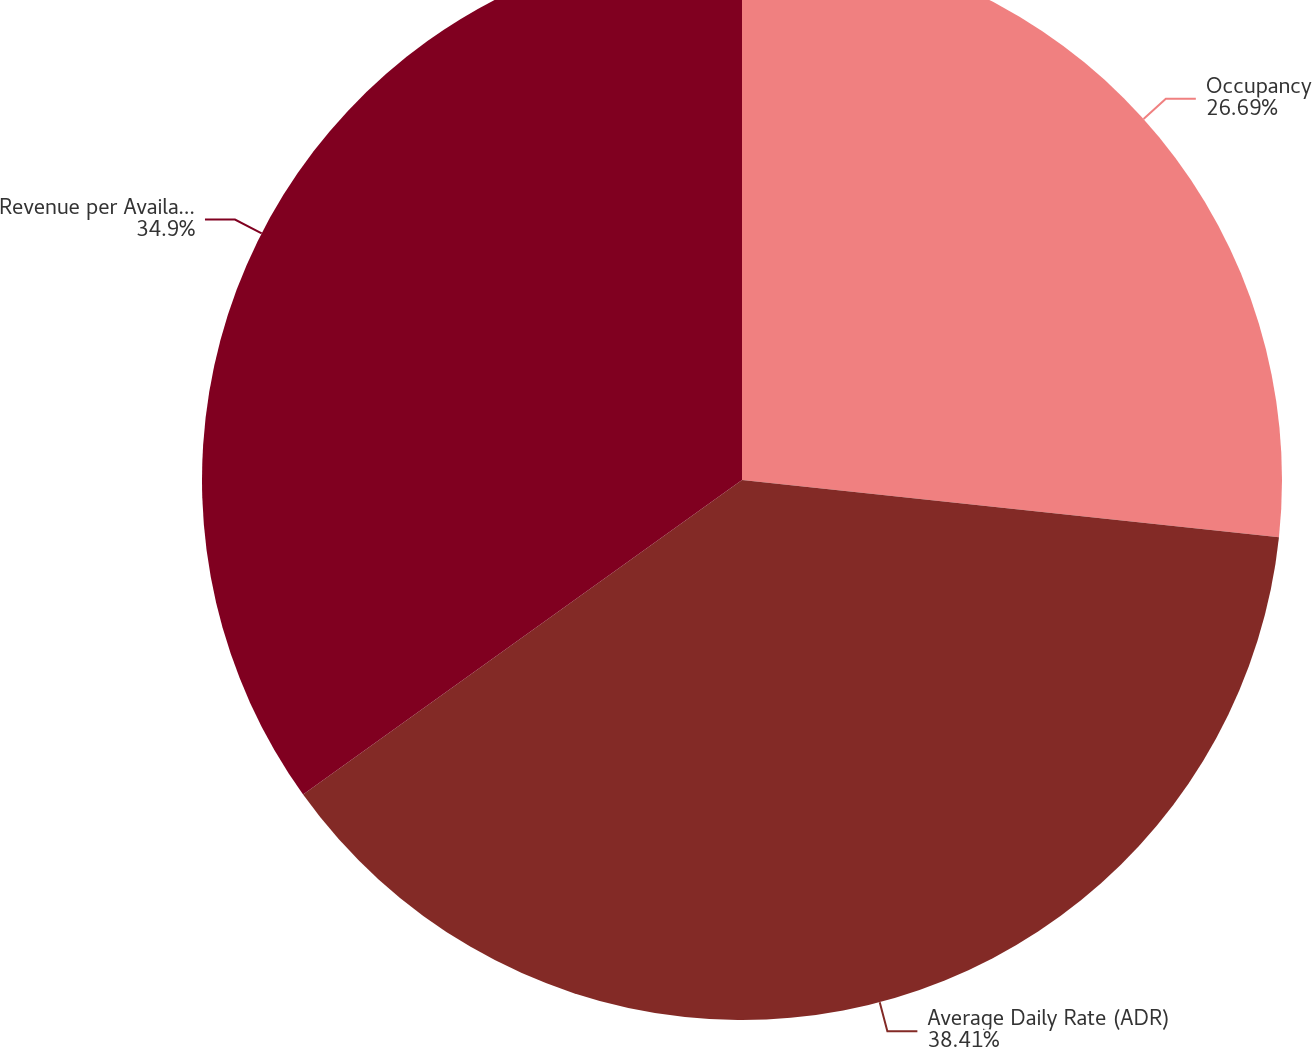Convert chart. <chart><loc_0><loc_0><loc_500><loc_500><pie_chart><fcel>Occupancy<fcel>Average Daily Rate (ADR)<fcel>Revenue per Available Room<nl><fcel>26.69%<fcel>38.42%<fcel>34.9%<nl></chart> 